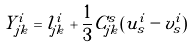<formula> <loc_0><loc_0><loc_500><loc_500>Y ^ { i } _ { j k } = l ^ { i } _ { j k } + \frac { 1 } { 3 } C ^ { s } _ { j k } ( u ^ { i } _ { s } - v ^ { i } _ { s } )</formula> 